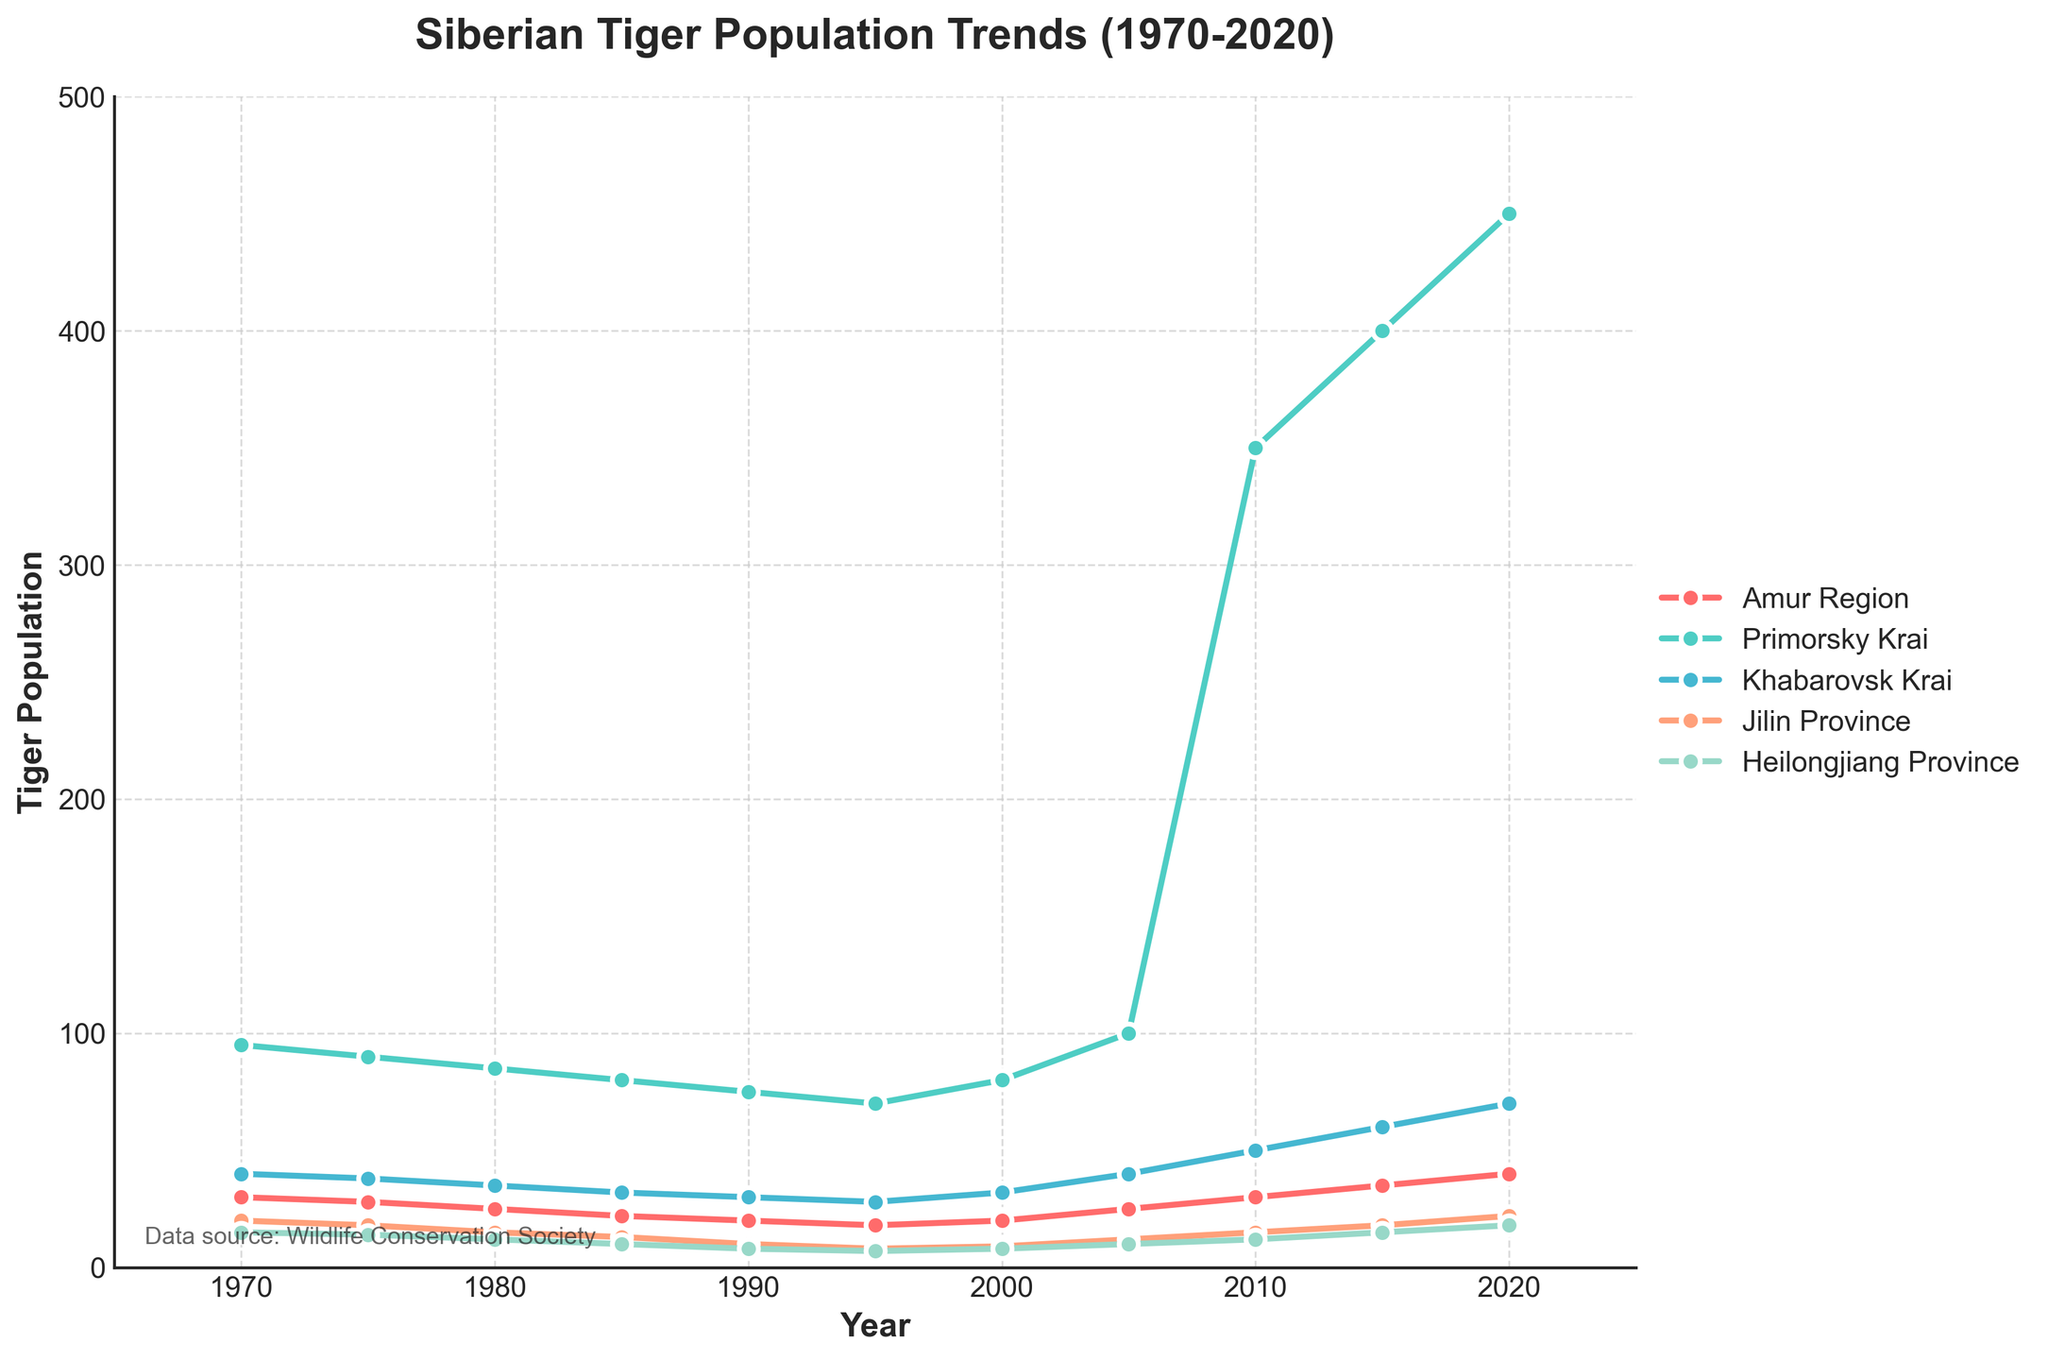How many times did the tiger population in Primorsky Krai reach a peak over the past 50 years? The tiger population in Primorsky Krai increased dramatically between 2005 and 2010 from 100 to 350 and further to 450 in 2020. Therefore, it reached its peak once during this period.
Answer: Once Which region experienced the most significant population decrease from 1970 to 1995? By comparing the tiger populations in each region from 1970 to 1995, the Amur Region decreased from 30 to 18 (-12), Primorsky Krai from 95 to 70 (-25), Khabarovsk Krai from 40 to 28 (-12), Jilin Province from 20 to 8 (-12), and Heilongjiang Province from 15 to 7 (-8). The largest decrease is in Primorsky Krai (-25).
Answer: Primorsky Krai What is the average population growth of tigers in the Amur Region from 1990 to 2020? Calculate the differences in population for each interval: 1990-1995: (18-20)=-2, 1995-2000: (20-18)=2, 2000-2005: (25-20)=5, 2005-2010: (30-25)=5, 2010-2015: (35-30)=5, 2015-2020: (40-35)=5. Sum these differences: -2+2+5+5+5+5=20. There are 6 intervals, so the average growth per interval is 20/6 ≈ 3.33
Answer: 3.33 Which two regions showed a similar trend in tiger population changes from 1970 to 2020? By examining the plotted lines, the Amur Region and Heilongjiang Province both show a general trend of decline from 1970 to 1995 and then gradual growth from 2000 to 2020.
Answer: Amur Region and Heilongjiang Province In which year did Jilin Province and Heilongjiang Province have the same tiger population? By looking at the chart and the data, both Jilin Province and Heilongjiang Province had a tiger population of 8 in the year 1995.
Answer: 1995 How many regions experienced a tiger population increase from 2010 to 2020? Check the population values in 2010 and 2020 for each region: Amur Region (30 to 40), Primorsky Krai (350 to 450), Khabarovsk Krai (50 to 70), Jilin Province (15 to 22), Heilongjiang Province (12 to 18). All five regions showed an increase, so the answer is 5 regions.
Answer: 5 Which region had the smallest tiger population in 2020 and what was the population? From the data, the smallest tiger population in 2020 is in Jilin Province (22).
Answer: Jilin Province, 22 By what percentage did the tiger population in Primorsky Krai increase between 2010 and 2020? Calculate the percentage increase using the formula [(450-350)/350]*100 = [100/350]*100 ≈ 28.57%.
Answer: 28.57% What was the difference in tiger populations between the Amur Region and Khabarovsk Krai in 1970? Subtract the population in the Amur Region (30) from the population in Khabarovsk Krai (40) in 1970: 40-30 = 10.
Answer: 10 In which region and in which year did the highest tiger population occur? Based on the data and the chart, the highest tiger population occurred in Primorsky Krai in the year 2020 with a population of 450.
Answer: Primorsky Krai, 2020 